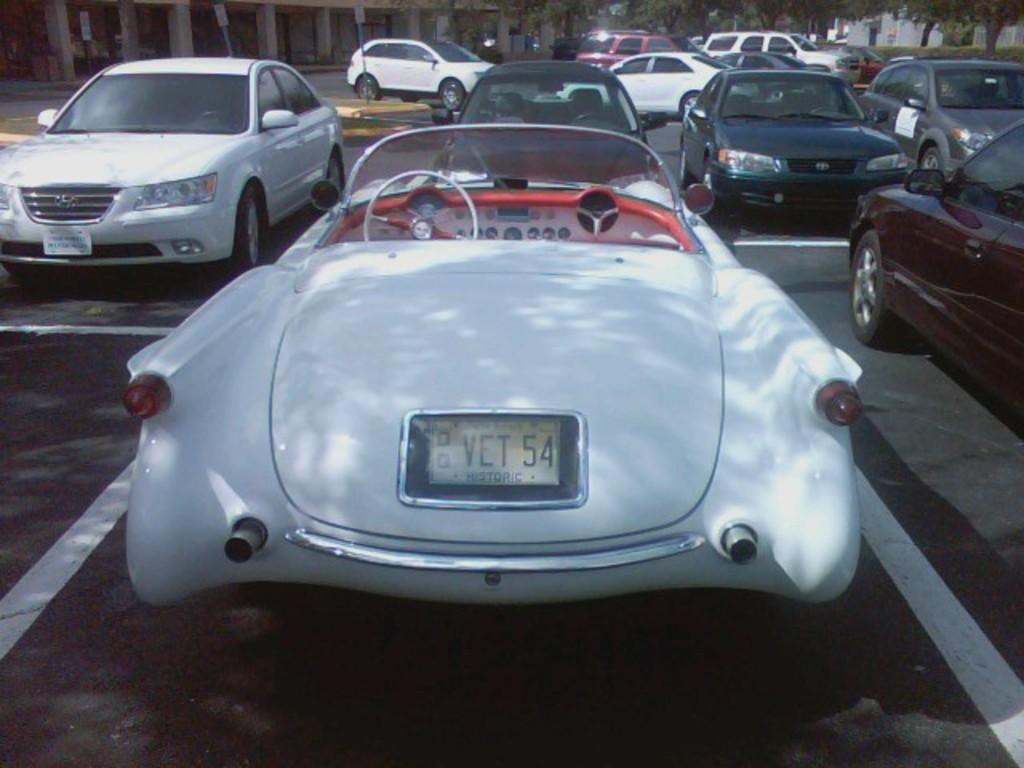What can be seen on the road in the image? There are many cars on the road in the image. What type of natural elements are visible in the image? There are trees visible at the top of the image. What structure can be seen on the left side of the image? There appears to be a building on the left side of the image. Where is the rabbit wearing a collar in the image? There is no rabbit wearing a collar present in the image. What type of notebook is being used by the cars on the road? There is no notebook visible in the image, as it features cars on the road, trees, and a building. 